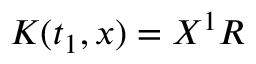Convert formula to latex. <formula><loc_0><loc_0><loc_500><loc_500>K ( t _ { 1 } , x ) = X ^ { 1 } R</formula> 